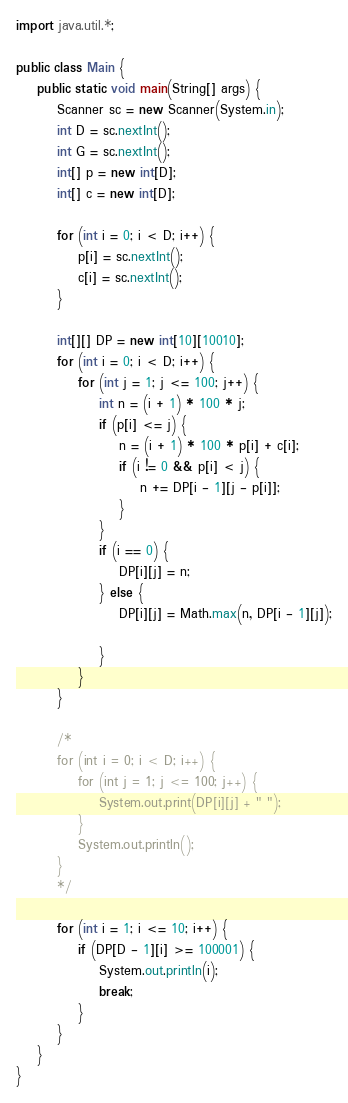Convert code to text. <code><loc_0><loc_0><loc_500><loc_500><_Java_>import java.util.*;

public class Main {
    public static void main(String[] args) {
        Scanner sc = new Scanner(System.in);
        int D = sc.nextInt();
        int G = sc.nextInt();
        int[] p = new int[D];
        int[] c = new int[D];

        for (int i = 0; i < D; i++) {
            p[i] = sc.nextInt();
            c[i] = sc.nextInt();
        }

        int[][] DP = new int[10][10010];
        for (int i = 0; i < D; i++) {
            for (int j = 1; j <= 100; j++) {
                int n = (i + 1) * 100 * j;
                if (p[i] <= j) {
                    n = (i + 1) * 100 * p[i] + c[i];
                    if (i != 0 && p[i] < j) {
                        n += DP[i - 1][j - p[i]];
                    }
                }
                if (i == 0) {
                    DP[i][j] = n;
                } else {
                    DP[i][j] = Math.max(n, DP[i - 1][j]);

                }
            }
        }

        /*
        for (int i = 0; i < D; i++) {
            for (int j = 1; j <= 100; j++) {
                System.out.print(DP[i][j] + " ");
            }
            System.out.println();
        }
        */

        for (int i = 1; i <= 10; i++) {
            if (DP[D - 1][i] >= 100001) {
                System.out.println(i);
                break;
            }
        }
    }
}
</code> 